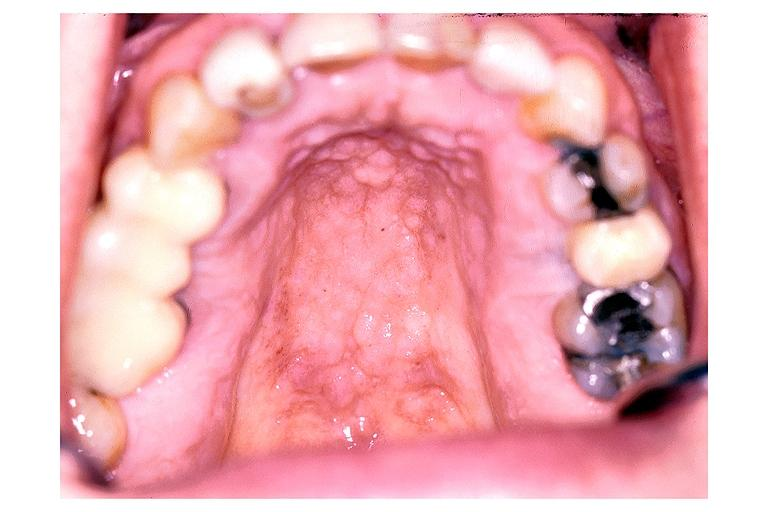what does this image show?
Answer the question using a single word or phrase. Inflamatory papillary hyperplasia 